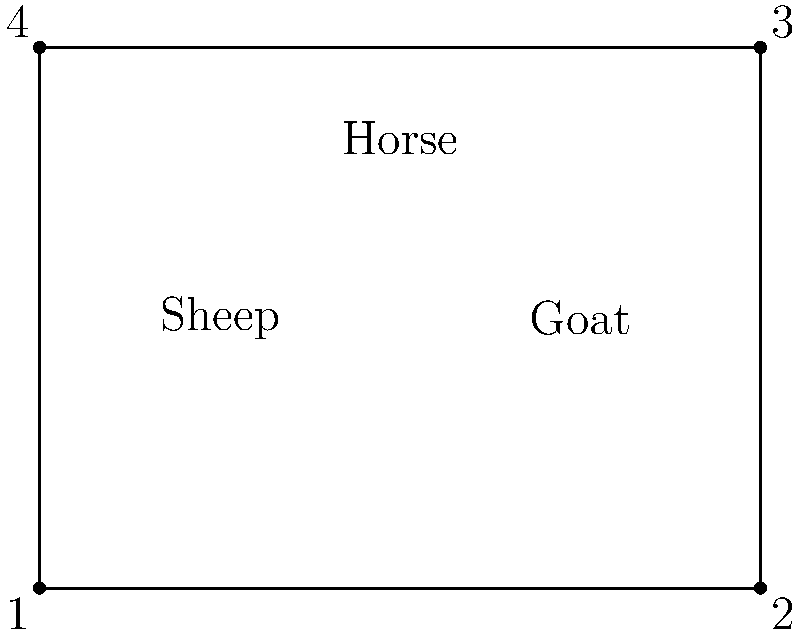In your fenced grazing area, you have three different types of livestock: sheep, goats, and horses. How many different ways can you arrange these animals in the four corners of the fence, assuming you place one animal type in each corner and leave one corner empty? To solve this problem, we'll use the concept of permutations:

1. First, we need to choose which corner will be left empty. There are 4 choices for this.

2. After choosing the empty corner, we need to arrange the 3 types of animals in the remaining 3 corners.

3. Arranging 3 different objects in 3 positions is a permutation, denoted as $P(3,3)$ or $3!$.

4. The number of permutations is calculated as:
   $P(3,3) = 3! = 3 \times 2 \times 1 = 6$

5. For each choice of the empty corner, we have 6 different arrangements of the animals.

6. Therefore, the total number of possible arrangements is:
   $4 \times 6 = 24$

This can also be thought of as a permutation of 4 objects (3 animals + 1 empty space), which is $4! = 4 \times 3 \times 2 \times 1 = 24$.
Answer: 24 